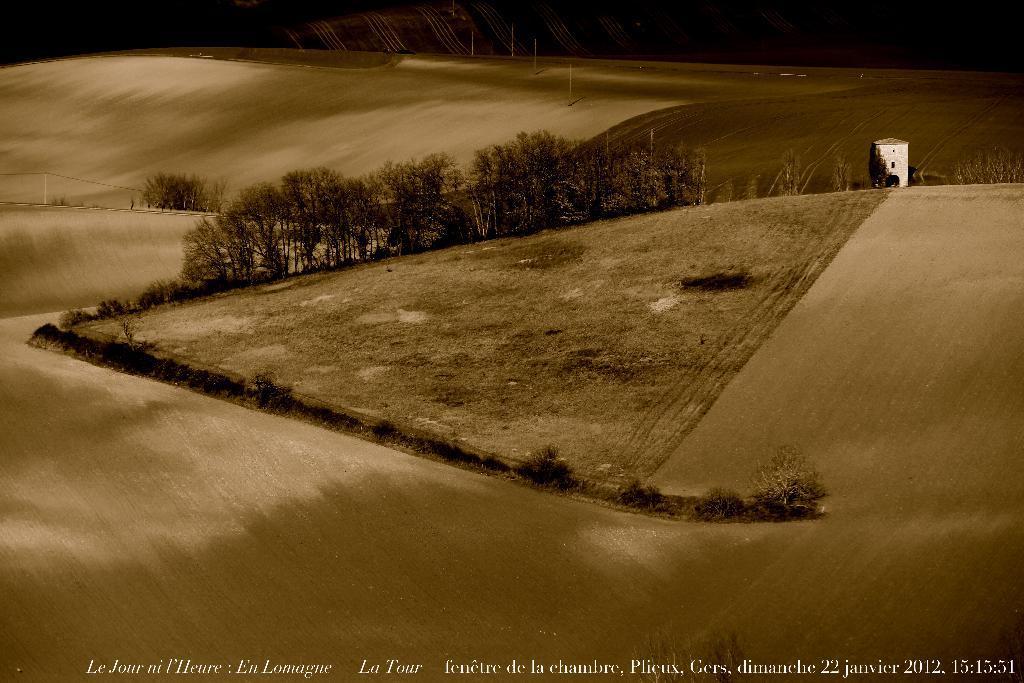Can you describe this image briefly? In this image I can see the ground, many trees and the building. And there is a black background. 